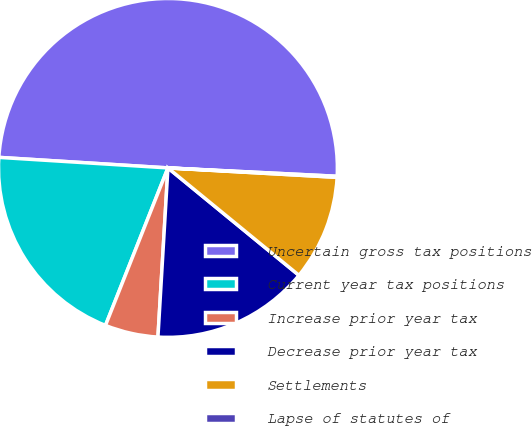Convert chart. <chart><loc_0><loc_0><loc_500><loc_500><pie_chart><fcel>Uncertain gross tax positions<fcel>Current year tax positions<fcel>Increase prior year tax<fcel>Decrease prior year tax<fcel>Settlements<fcel>Lapse of statutes of<nl><fcel>49.79%<fcel>19.98%<fcel>5.07%<fcel>15.01%<fcel>10.04%<fcel>0.1%<nl></chart> 